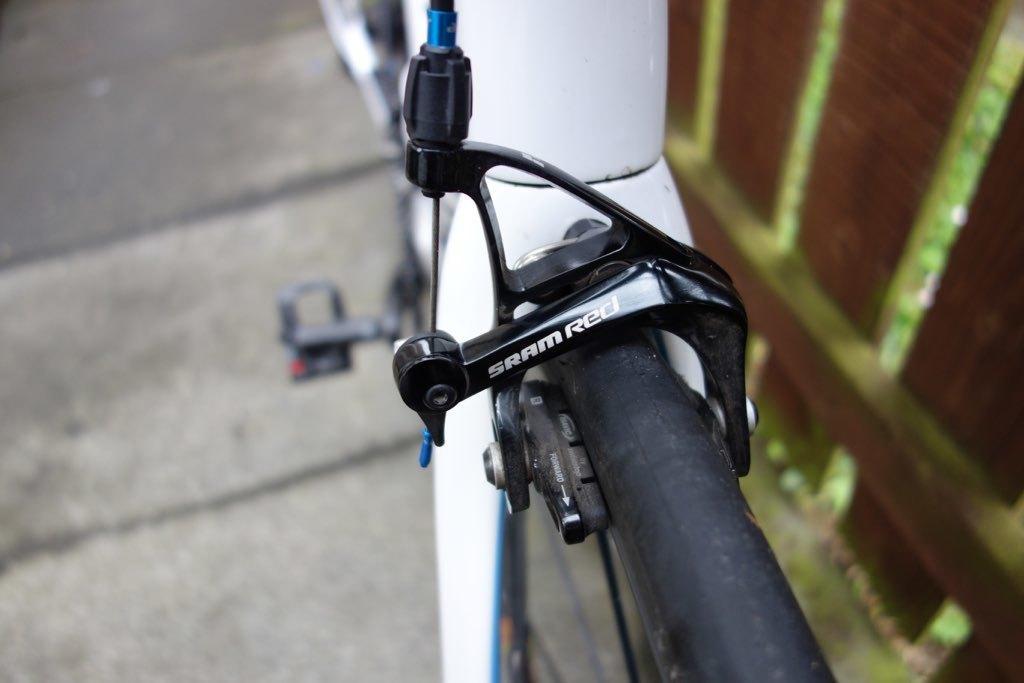Please provide a concise description of this image. In this image I can see a bicycle with some text written on it. On the right side, I can see the wooden railing. 